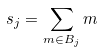Convert formula to latex. <formula><loc_0><loc_0><loc_500><loc_500>s _ { j } = \sum _ { m \in B _ { j } } m</formula> 